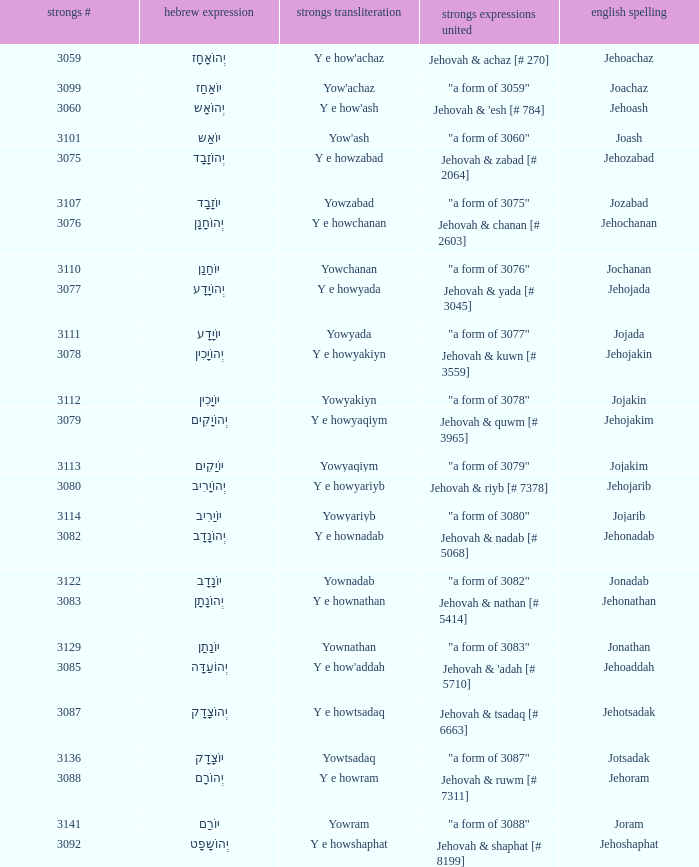What is the strongs transliteration of the hebrew word יוֹחָנָן? Yowchanan. 